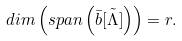<formula> <loc_0><loc_0><loc_500><loc_500>d i m \left ( s p a n \left ( \bar { b } \tilde { \left [ \Lambda \right ] } \right ) \right ) = r .</formula> 